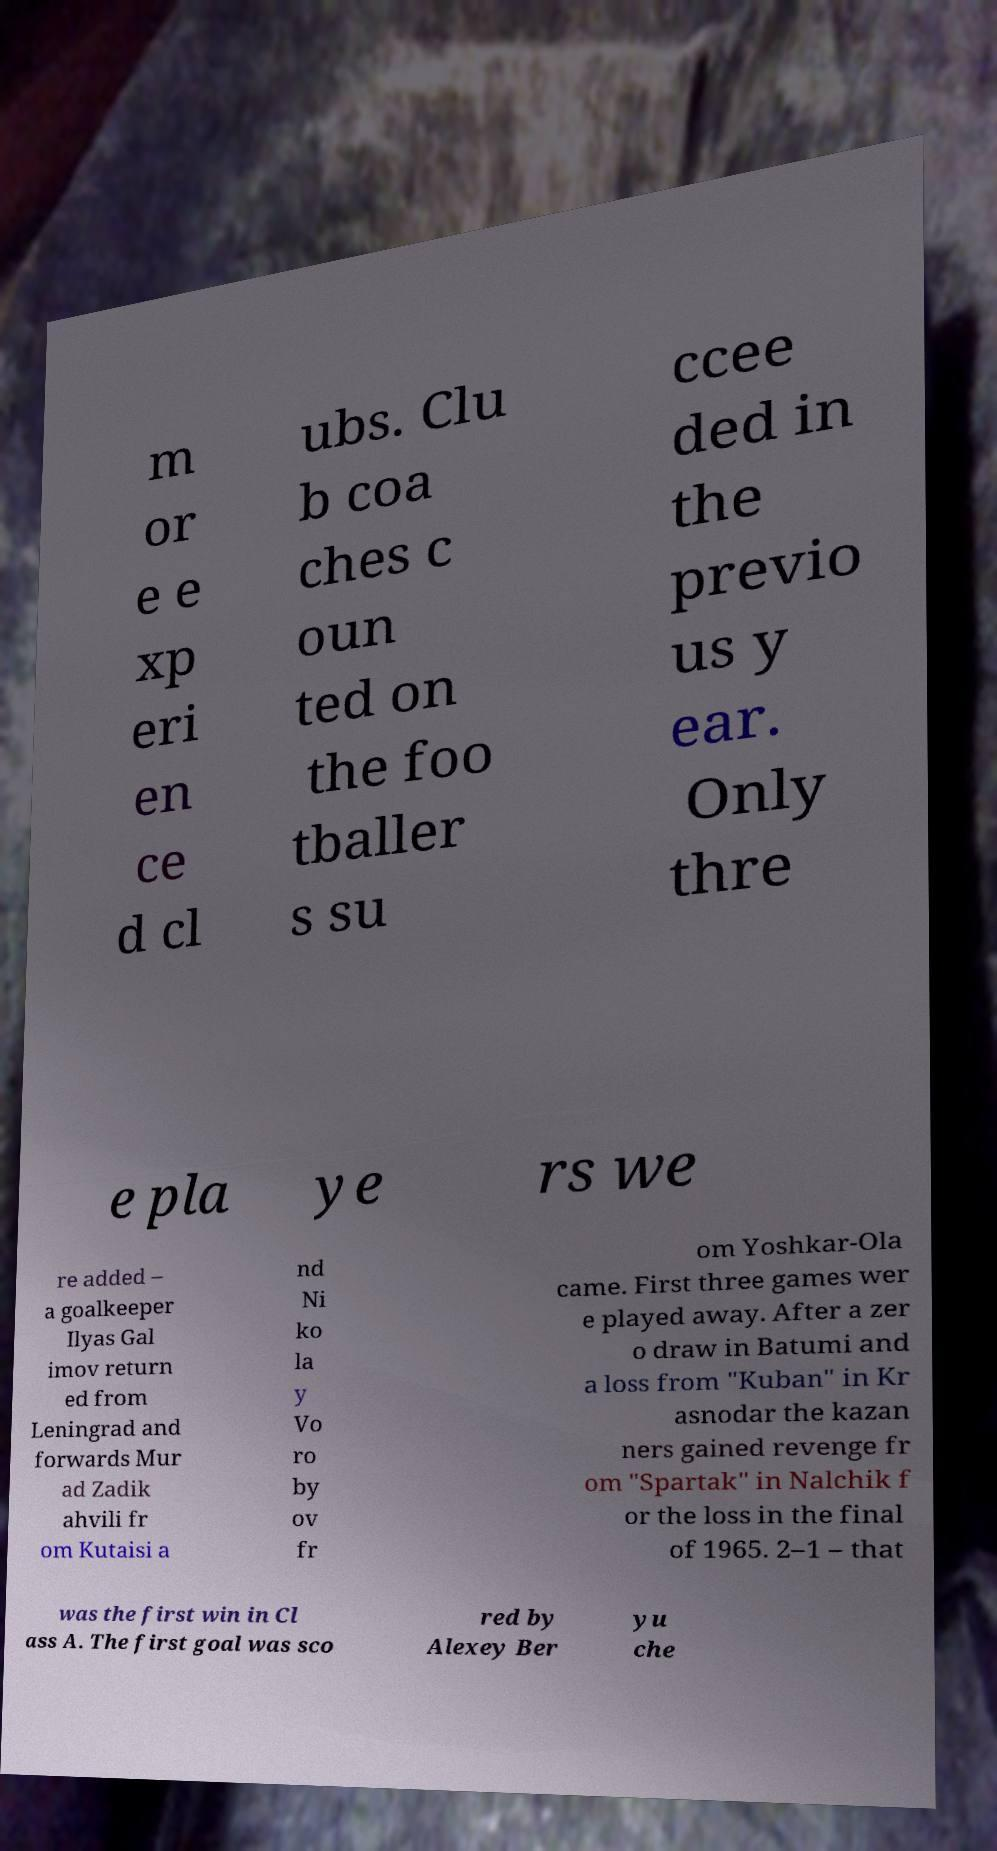There's text embedded in this image that I need extracted. Can you transcribe it verbatim? m or e e xp eri en ce d cl ubs. Clu b coa ches c oun ted on the foo tballer s su ccee ded in the previo us y ear. Only thre e pla ye rs we re added – a goalkeeper Ilyas Gal imov return ed from Leningrad and forwards Mur ad Zadik ahvili fr om Kutaisi a nd Ni ko la y Vo ro by ov fr om Yoshkar-Ola came. First three games wer e played away. After a zer o draw in Batumi and a loss from "Kuban" in Kr asnodar the kazan ners gained revenge fr om "Spartak" in Nalchik f or the loss in the final of 1965. 2–1 – that was the first win in Cl ass A. The first goal was sco red by Alexey Ber yu che 